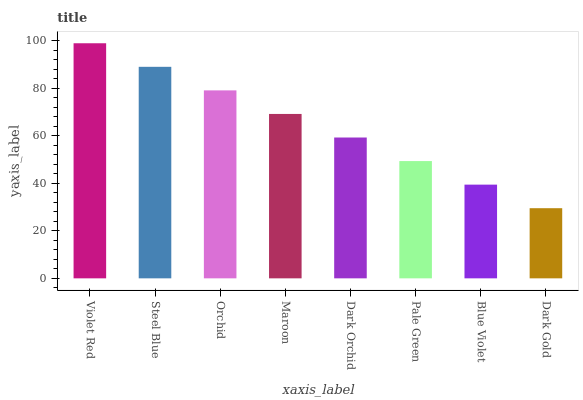Is Dark Gold the minimum?
Answer yes or no. Yes. Is Violet Red the maximum?
Answer yes or no. Yes. Is Steel Blue the minimum?
Answer yes or no. No. Is Steel Blue the maximum?
Answer yes or no. No. Is Violet Red greater than Steel Blue?
Answer yes or no. Yes. Is Steel Blue less than Violet Red?
Answer yes or no. Yes. Is Steel Blue greater than Violet Red?
Answer yes or no. No. Is Violet Red less than Steel Blue?
Answer yes or no. No. Is Maroon the high median?
Answer yes or no. Yes. Is Dark Orchid the low median?
Answer yes or no. Yes. Is Violet Red the high median?
Answer yes or no. No. Is Pale Green the low median?
Answer yes or no. No. 